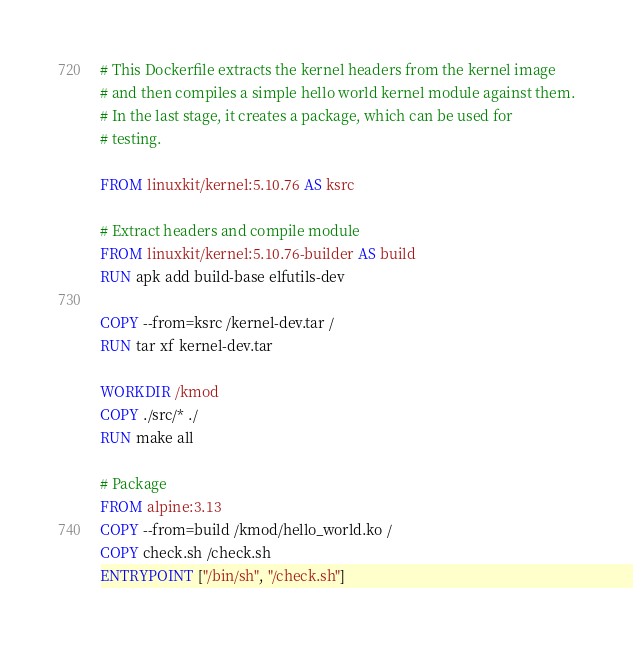<code> <loc_0><loc_0><loc_500><loc_500><_Dockerfile_># This Dockerfile extracts the kernel headers from the kernel image
# and then compiles a simple hello world kernel module against them.
# In the last stage, it creates a package, which can be used for
# testing.

FROM linuxkit/kernel:5.10.76 AS ksrc

# Extract headers and compile module
FROM linuxkit/kernel:5.10.76-builder AS build
RUN apk add build-base elfutils-dev

COPY --from=ksrc /kernel-dev.tar /
RUN tar xf kernel-dev.tar

WORKDIR /kmod
COPY ./src/* ./
RUN make all

# Package
FROM alpine:3.13
COPY --from=build /kmod/hello_world.ko /
COPY check.sh /check.sh
ENTRYPOINT ["/bin/sh", "/check.sh"]
</code> 